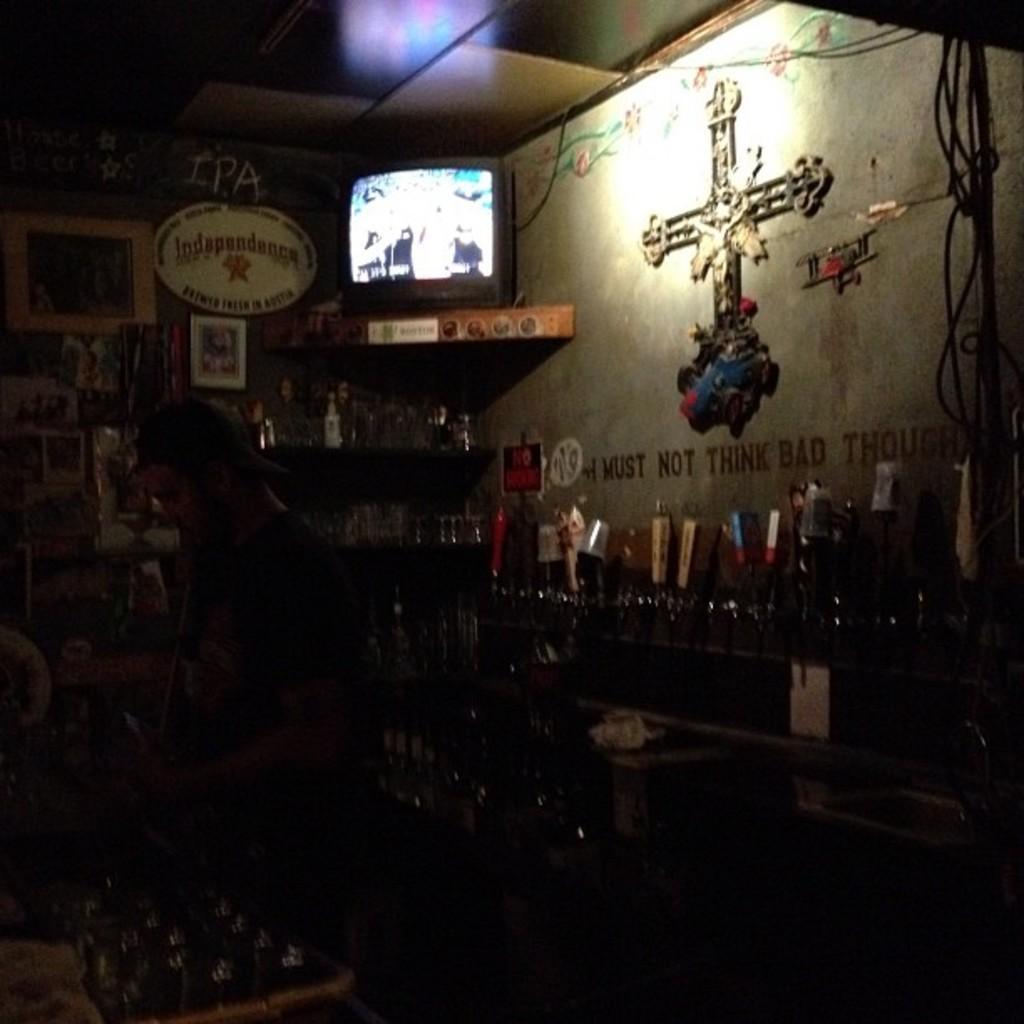Could you give a brief overview of what you see in this image? In this image I can see dark view and I can see a monitor kept on the table and the table is attached to the wall. 